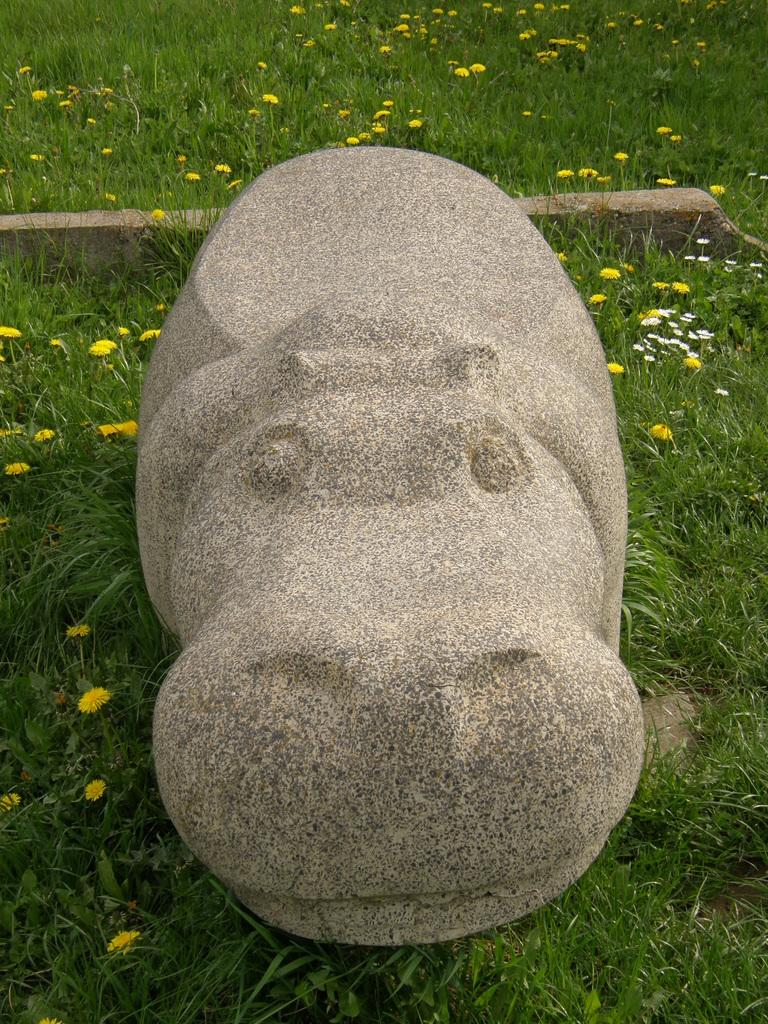What is the main subject of the image? There is a sculpture in the image. Where is the sculpture located? The sculpture is located in a garden. What type of land is the sculpture standing on in the image? The provided facts do not mention the type of land the sculpture is standing on, so we cannot answer this question definitively. 